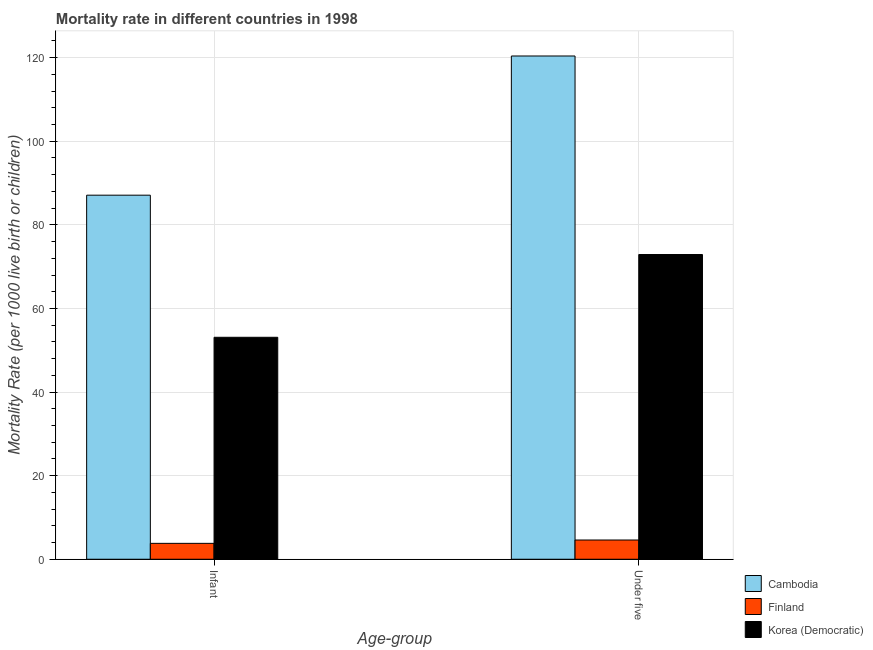How many different coloured bars are there?
Your answer should be compact. 3. How many bars are there on the 2nd tick from the right?
Provide a succinct answer. 3. What is the label of the 2nd group of bars from the left?
Provide a short and direct response. Under five. What is the under-5 mortality rate in Korea (Democratic)?
Give a very brief answer. 72.9. Across all countries, what is the maximum under-5 mortality rate?
Provide a succinct answer. 120.4. Across all countries, what is the minimum infant mortality rate?
Provide a succinct answer. 3.8. In which country was the infant mortality rate maximum?
Provide a succinct answer. Cambodia. In which country was the under-5 mortality rate minimum?
Your answer should be compact. Finland. What is the total infant mortality rate in the graph?
Keep it short and to the point. 144. What is the difference between the under-5 mortality rate in Cambodia and that in Finland?
Offer a very short reply. 115.8. What is the difference between the infant mortality rate in Finland and the under-5 mortality rate in Cambodia?
Keep it short and to the point. -116.6. What is the difference between the infant mortality rate and under-5 mortality rate in Korea (Democratic)?
Your response must be concise. -19.8. In how many countries, is the infant mortality rate greater than 20 ?
Ensure brevity in your answer.  2. What is the ratio of the under-5 mortality rate in Cambodia to that in Finland?
Keep it short and to the point. 26.17. In how many countries, is the under-5 mortality rate greater than the average under-5 mortality rate taken over all countries?
Offer a very short reply. 2. What does the 2nd bar from the left in Under five represents?
Provide a short and direct response. Finland. What does the 3rd bar from the right in Under five represents?
Your answer should be compact. Cambodia. How many bars are there?
Provide a short and direct response. 6. How many countries are there in the graph?
Keep it short and to the point. 3. What is the difference between two consecutive major ticks on the Y-axis?
Offer a very short reply. 20. Does the graph contain any zero values?
Ensure brevity in your answer.  No. Does the graph contain grids?
Your answer should be very brief. Yes. Where does the legend appear in the graph?
Provide a short and direct response. Bottom right. What is the title of the graph?
Give a very brief answer. Mortality rate in different countries in 1998. Does "Tanzania" appear as one of the legend labels in the graph?
Give a very brief answer. No. What is the label or title of the X-axis?
Your answer should be compact. Age-group. What is the label or title of the Y-axis?
Offer a terse response. Mortality Rate (per 1000 live birth or children). What is the Mortality Rate (per 1000 live birth or children) of Cambodia in Infant?
Provide a short and direct response. 87.1. What is the Mortality Rate (per 1000 live birth or children) in Finland in Infant?
Your answer should be compact. 3.8. What is the Mortality Rate (per 1000 live birth or children) in Korea (Democratic) in Infant?
Offer a very short reply. 53.1. What is the Mortality Rate (per 1000 live birth or children) in Cambodia in Under five?
Keep it short and to the point. 120.4. What is the Mortality Rate (per 1000 live birth or children) of Korea (Democratic) in Under five?
Keep it short and to the point. 72.9. Across all Age-group, what is the maximum Mortality Rate (per 1000 live birth or children) of Cambodia?
Ensure brevity in your answer.  120.4. Across all Age-group, what is the maximum Mortality Rate (per 1000 live birth or children) of Korea (Democratic)?
Offer a very short reply. 72.9. Across all Age-group, what is the minimum Mortality Rate (per 1000 live birth or children) of Cambodia?
Offer a terse response. 87.1. Across all Age-group, what is the minimum Mortality Rate (per 1000 live birth or children) of Korea (Democratic)?
Offer a terse response. 53.1. What is the total Mortality Rate (per 1000 live birth or children) in Cambodia in the graph?
Offer a terse response. 207.5. What is the total Mortality Rate (per 1000 live birth or children) in Finland in the graph?
Ensure brevity in your answer.  8.4. What is the total Mortality Rate (per 1000 live birth or children) of Korea (Democratic) in the graph?
Make the answer very short. 126. What is the difference between the Mortality Rate (per 1000 live birth or children) in Cambodia in Infant and that in Under five?
Make the answer very short. -33.3. What is the difference between the Mortality Rate (per 1000 live birth or children) in Korea (Democratic) in Infant and that in Under five?
Provide a succinct answer. -19.8. What is the difference between the Mortality Rate (per 1000 live birth or children) in Cambodia in Infant and the Mortality Rate (per 1000 live birth or children) in Finland in Under five?
Ensure brevity in your answer.  82.5. What is the difference between the Mortality Rate (per 1000 live birth or children) of Cambodia in Infant and the Mortality Rate (per 1000 live birth or children) of Korea (Democratic) in Under five?
Ensure brevity in your answer.  14.2. What is the difference between the Mortality Rate (per 1000 live birth or children) in Finland in Infant and the Mortality Rate (per 1000 live birth or children) in Korea (Democratic) in Under five?
Offer a terse response. -69.1. What is the average Mortality Rate (per 1000 live birth or children) of Cambodia per Age-group?
Provide a short and direct response. 103.75. What is the average Mortality Rate (per 1000 live birth or children) of Finland per Age-group?
Offer a terse response. 4.2. What is the difference between the Mortality Rate (per 1000 live birth or children) in Cambodia and Mortality Rate (per 1000 live birth or children) in Finland in Infant?
Make the answer very short. 83.3. What is the difference between the Mortality Rate (per 1000 live birth or children) in Cambodia and Mortality Rate (per 1000 live birth or children) in Korea (Democratic) in Infant?
Provide a short and direct response. 34. What is the difference between the Mortality Rate (per 1000 live birth or children) in Finland and Mortality Rate (per 1000 live birth or children) in Korea (Democratic) in Infant?
Offer a very short reply. -49.3. What is the difference between the Mortality Rate (per 1000 live birth or children) of Cambodia and Mortality Rate (per 1000 live birth or children) of Finland in Under five?
Offer a very short reply. 115.8. What is the difference between the Mortality Rate (per 1000 live birth or children) of Cambodia and Mortality Rate (per 1000 live birth or children) of Korea (Democratic) in Under five?
Ensure brevity in your answer.  47.5. What is the difference between the Mortality Rate (per 1000 live birth or children) of Finland and Mortality Rate (per 1000 live birth or children) of Korea (Democratic) in Under five?
Offer a very short reply. -68.3. What is the ratio of the Mortality Rate (per 1000 live birth or children) of Cambodia in Infant to that in Under five?
Offer a very short reply. 0.72. What is the ratio of the Mortality Rate (per 1000 live birth or children) of Finland in Infant to that in Under five?
Offer a very short reply. 0.83. What is the ratio of the Mortality Rate (per 1000 live birth or children) of Korea (Democratic) in Infant to that in Under five?
Provide a succinct answer. 0.73. What is the difference between the highest and the second highest Mortality Rate (per 1000 live birth or children) of Cambodia?
Offer a very short reply. 33.3. What is the difference between the highest and the second highest Mortality Rate (per 1000 live birth or children) in Finland?
Your response must be concise. 0.8. What is the difference between the highest and the second highest Mortality Rate (per 1000 live birth or children) in Korea (Democratic)?
Offer a very short reply. 19.8. What is the difference between the highest and the lowest Mortality Rate (per 1000 live birth or children) in Cambodia?
Offer a very short reply. 33.3. What is the difference between the highest and the lowest Mortality Rate (per 1000 live birth or children) in Finland?
Keep it short and to the point. 0.8. What is the difference between the highest and the lowest Mortality Rate (per 1000 live birth or children) in Korea (Democratic)?
Provide a succinct answer. 19.8. 